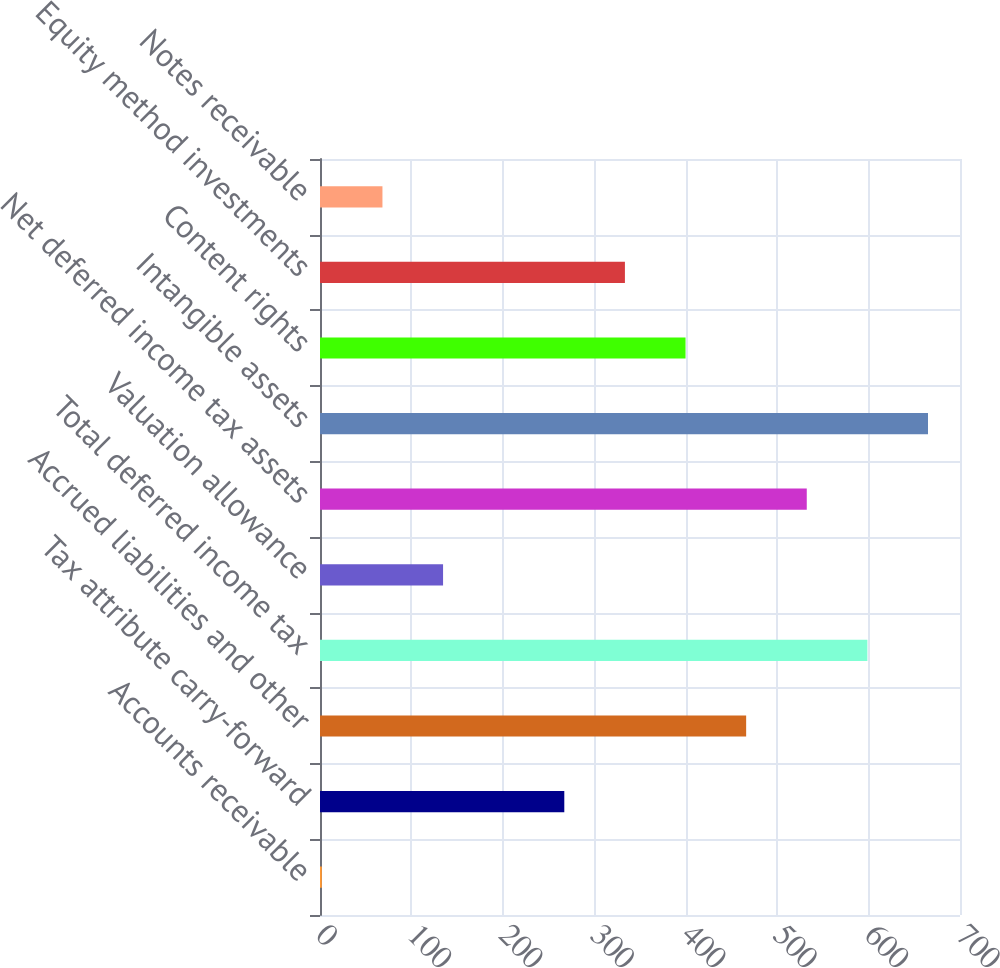<chart> <loc_0><loc_0><loc_500><loc_500><bar_chart><fcel>Accounts receivable<fcel>Tax attribute carry-forward<fcel>Accrued liabilities and other<fcel>Total deferred income tax<fcel>Valuation allowance<fcel>Net deferred income tax assets<fcel>Intangible assets<fcel>Content rights<fcel>Equity method investments<fcel>Notes receivable<nl><fcel>2<fcel>267.2<fcel>466.1<fcel>598.7<fcel>134.6<fcel>532.4<fcel>665<fcel>399.8<fcel>333.5<fcel>68.3<nl></chart> 